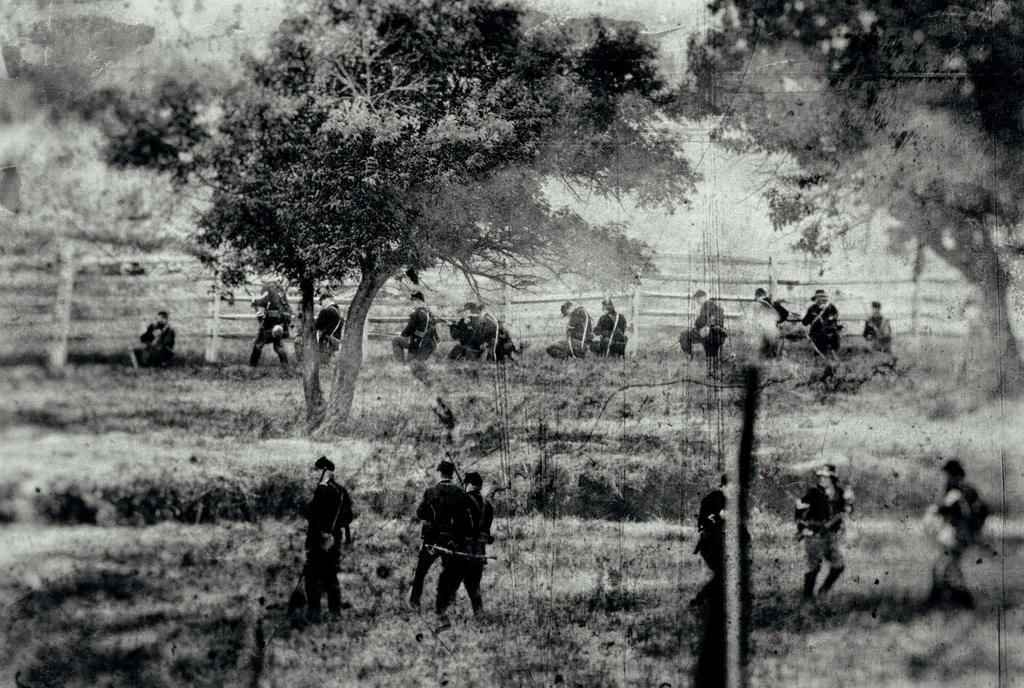How many people are in the image? There is a group of people in the image, but the exact number cannot be determined from the provided facts. What are the people in the image doing? Some people are standing, while others are sitting. What can be seen in the background of the image? There are trees, railing, and the sky visible in the background of the image. What is the color scheme of the image? The image is in black and white. Can you tell me how many rats are sitting on the railing in the image? There are no rats present in the image; it features a group of people with some standing and others sitting. What type of mitten is being worn by the person in the image? There is no mention of any mittens or apparel in the image, as it is in black and white and focuses on the group of people and their actions. 